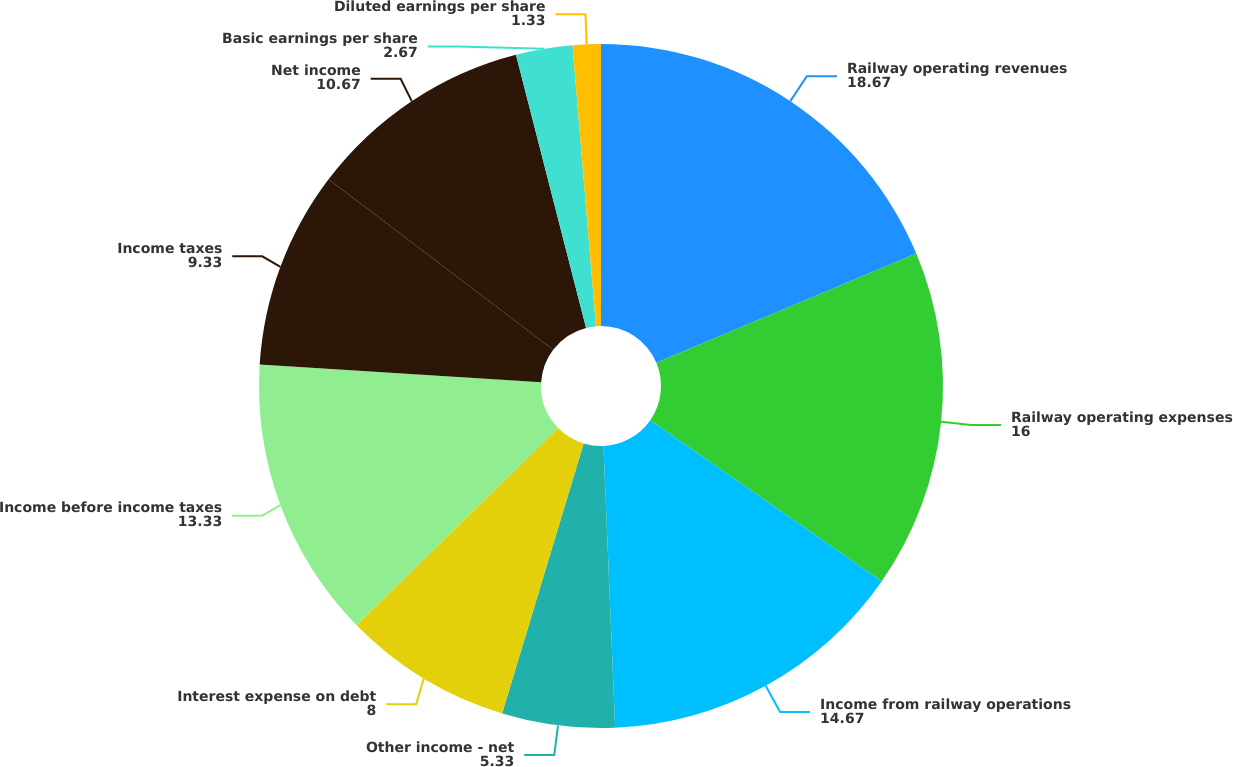<chart> <loc_0><loc_0><loc_500><loc_500><pie_chart><fcel>Railway operating revenues<fcel>Railway operating expenses<fcel>Income from railway operations<fcel>Other income - net<fcel>Interest expense on debt<fcel>Income before income taxes<fcel>Income taxes<fcel>Net income<fcel>Basic earnings per share<fcel>Diluted earnings per share<nl><fcel>18.67%<fcel>16.0%<fcel>14.67%<fcel>5.33%<fcel>8.0%<fcel>13.33%<fcel>9.33%<fcel>10.67%<fcel>2.67%<fcel>1.33%<nl></chart> 